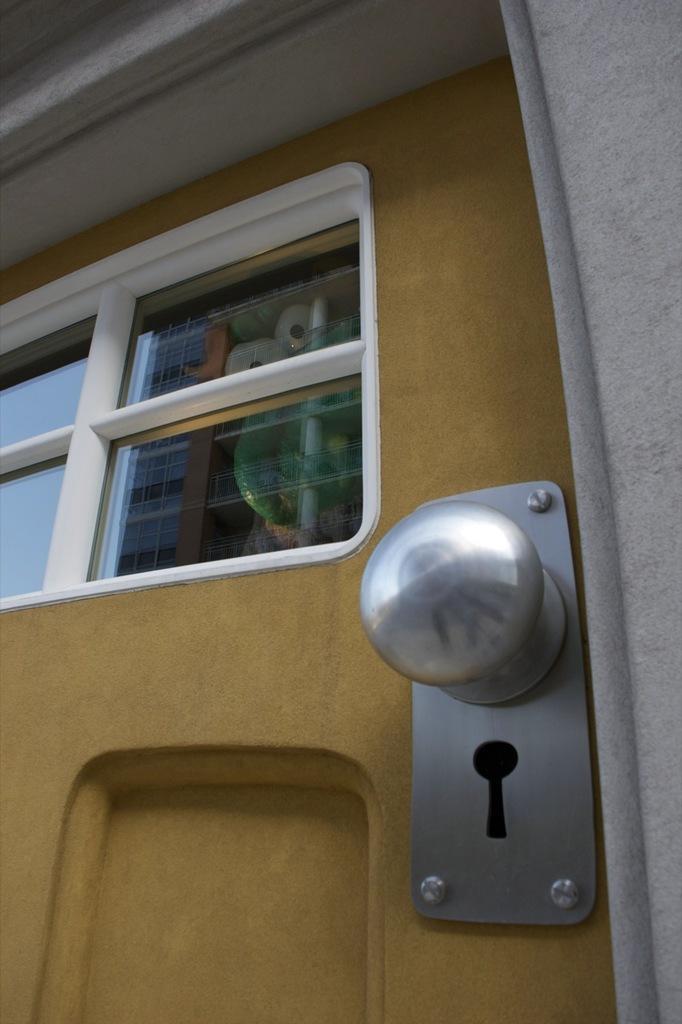Please provide a concise description of this image. In the image we can see there is a door and there is window on the door. There is a door handle on the door. 